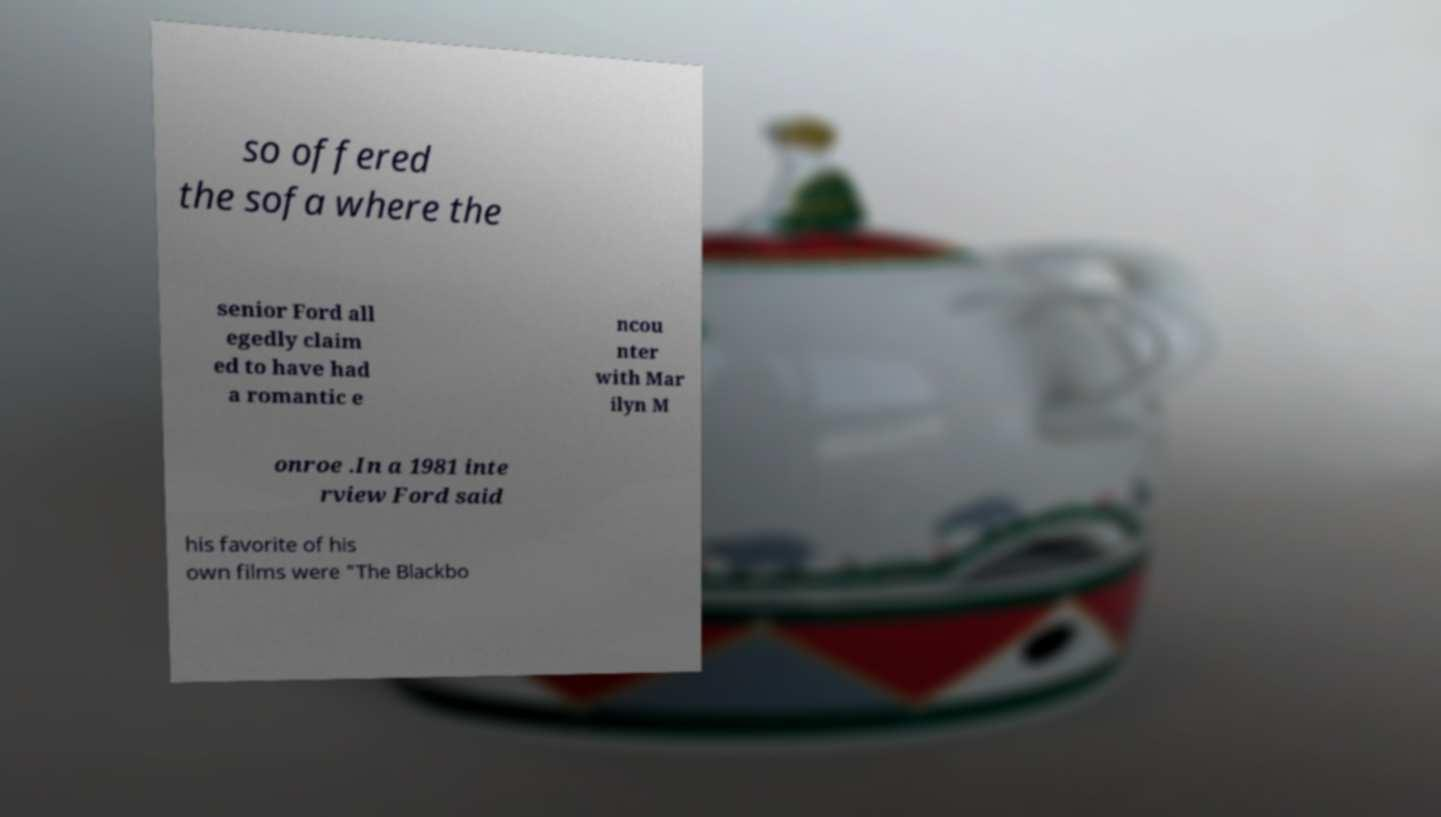I need the written content from this picture converted into text. Can you do that? so offered the sofa where the senior Ford all egedly claim ed to have had a romantic e ncou nter with Mar ilyn M onroe .In a 1981 inte rview Ford said his favorite of his own films were "The Blackbo 